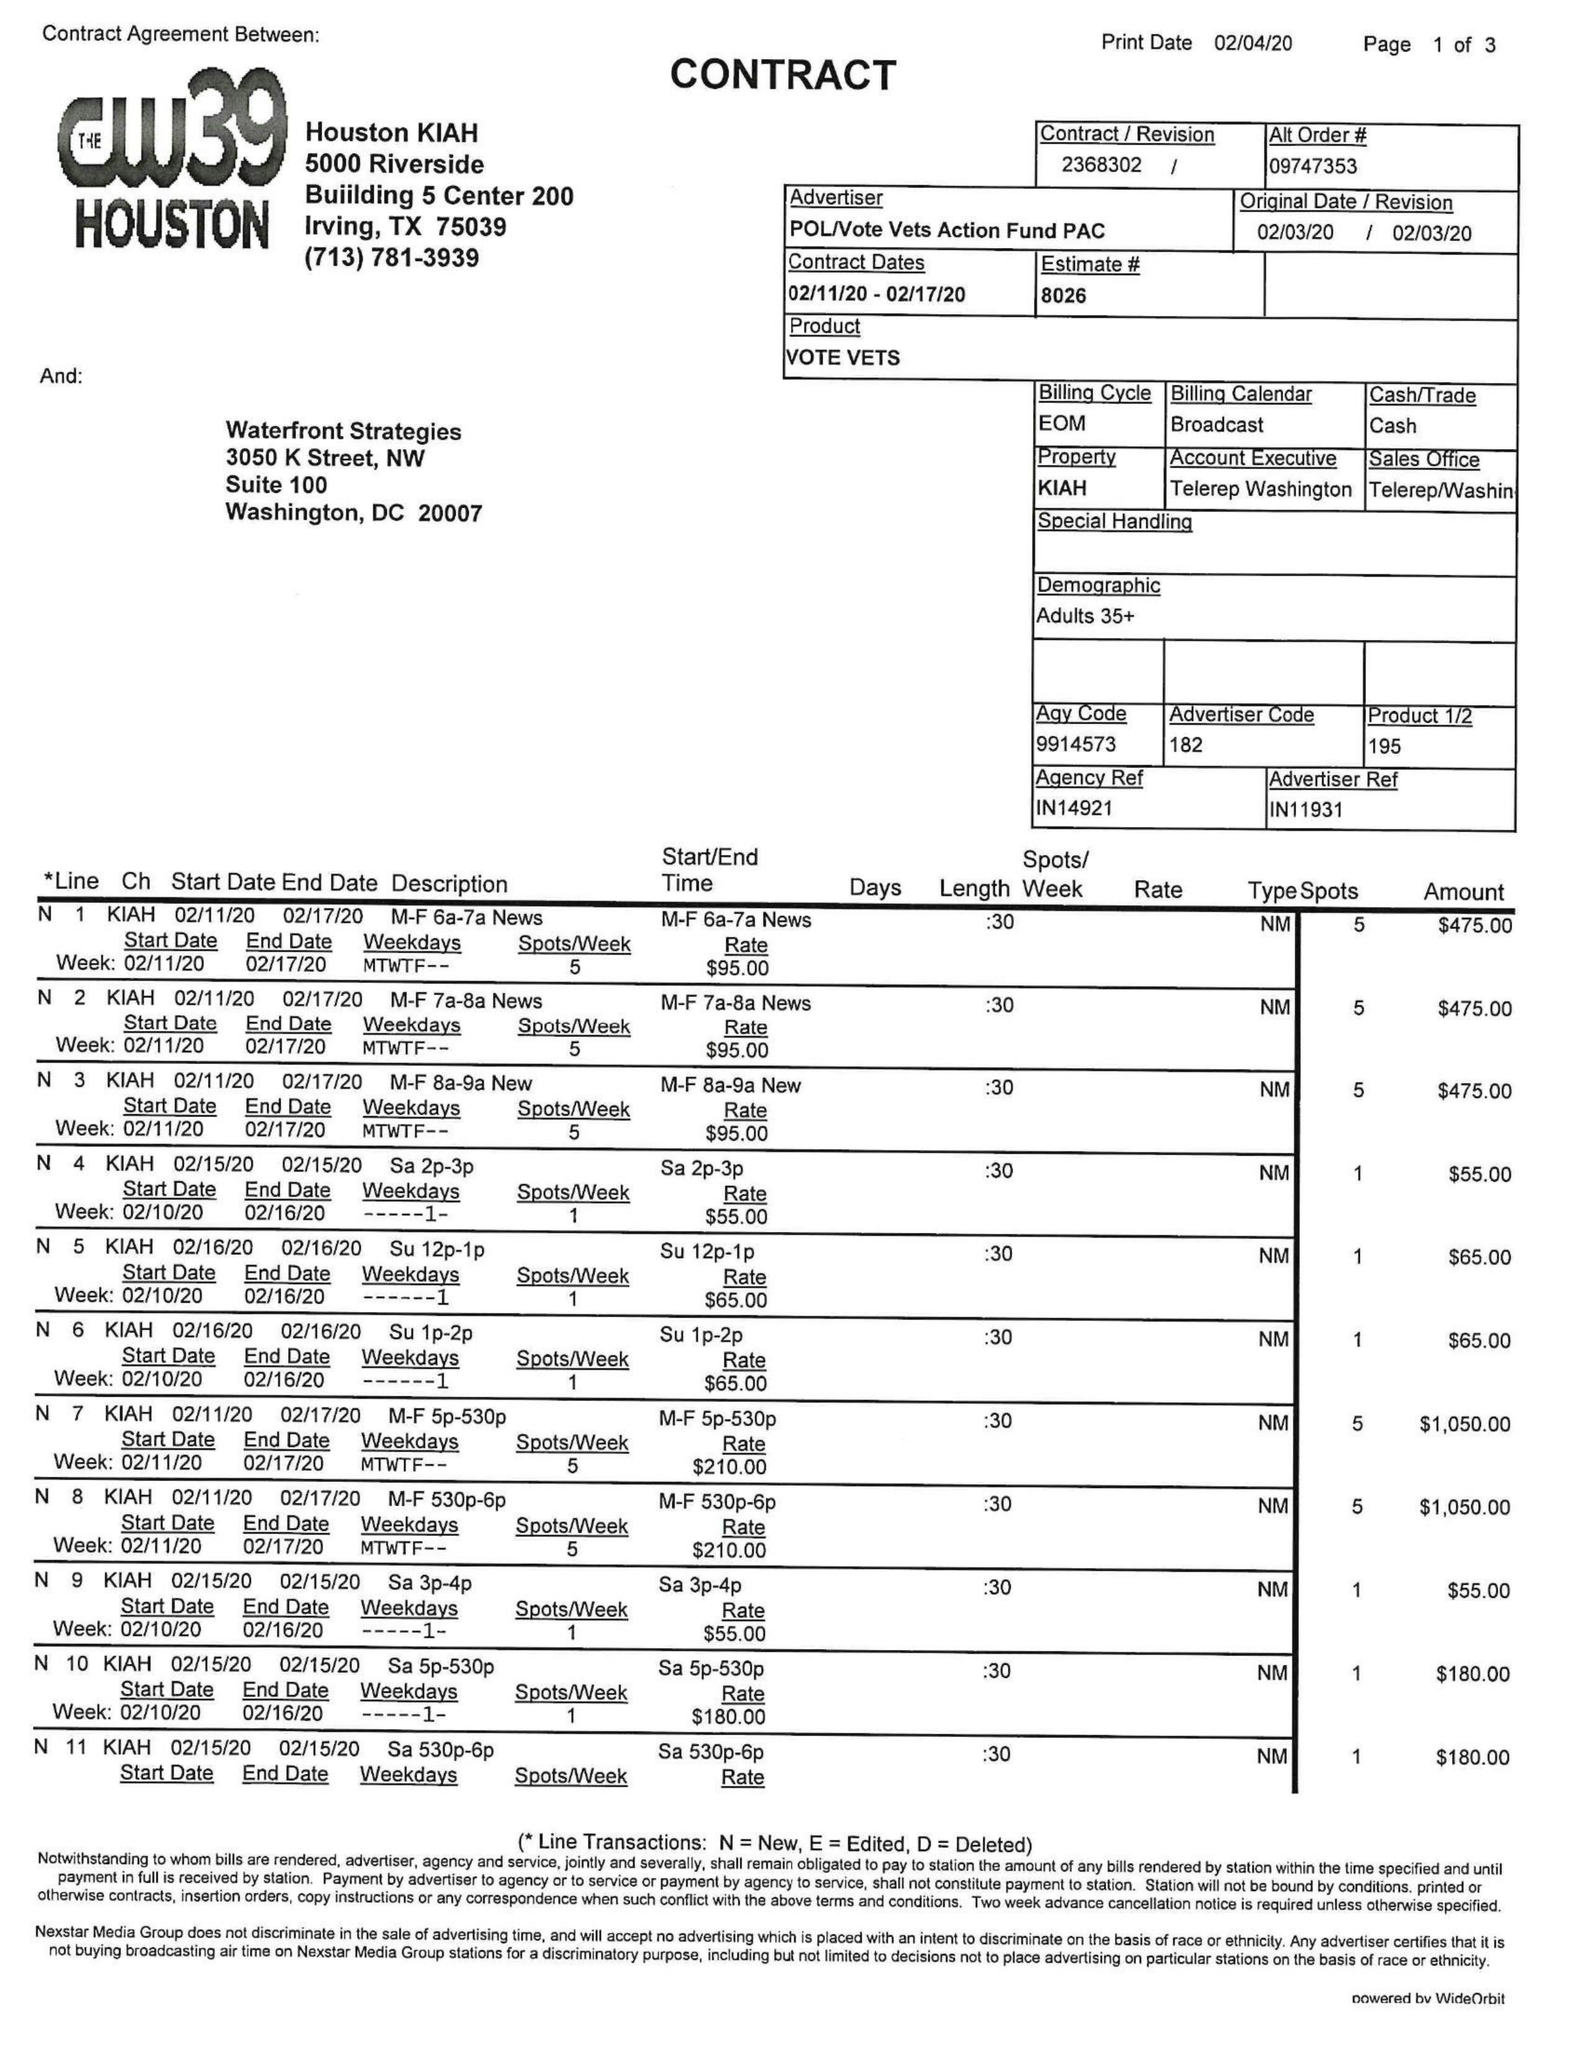What is the value for the advertiser?
Answer the question using a single word or phrase. POL/VOTEVETSACTIONFUNDPAC 